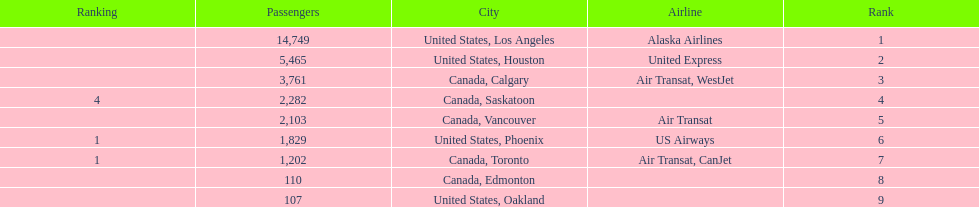What was the number of passengers in phoenix arizona? 1,829. 